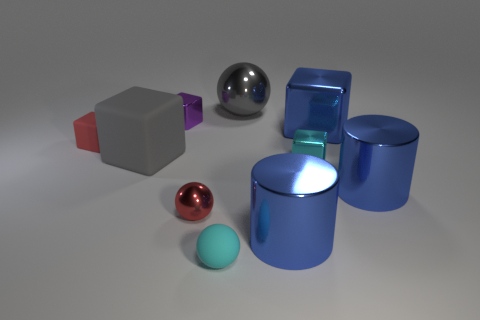How is the lighting arranged in this scene? The lighting in the scene appears to be coming from above, casting soft shadows beneath each object and giving the scene a uniformly lit appearance. Does the lighting create any reflections or highlights on the objects? Yes, the lighting creates visible reflections and highlights, particularly on the metallic objects where it emphasizes their shiny surfaces and curved shapes. 